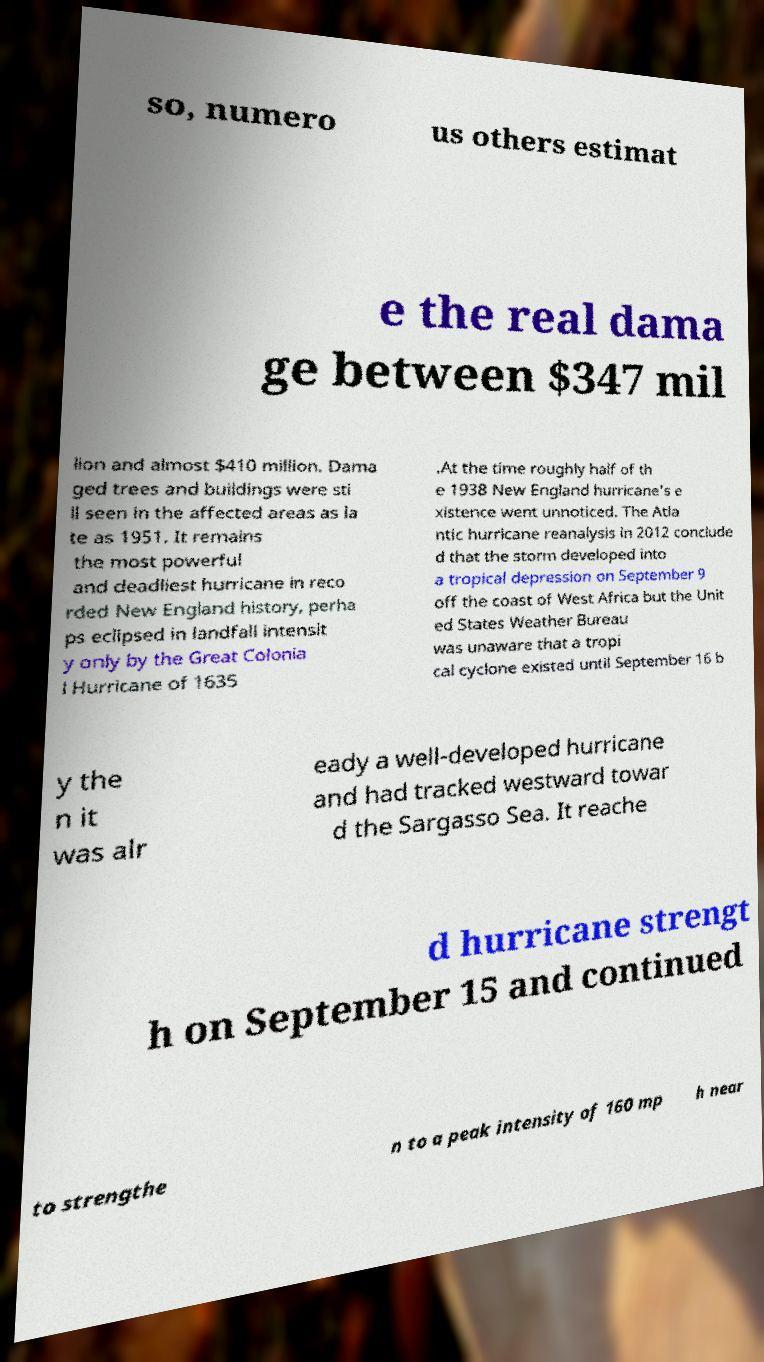Please identify and transcribe the text found in this image. so, numero us others estimat e the real dama ge between $347 mil lion and almost $410 million. Dama ged trees and buildings were sti ll seen in the affected areas as la te as 1951. It remains the most powerful and deadliest hurricane in reco rded New England history, perha ps eclipsed in landfall intensit y only by the Great Colonia l Hurricane of 1635 .At the time roughly half of th e 1938 New England hurricane's e xistence went unnoticed. The Atla ntic hurricane reanalysis in 2012 conclude d that the storm developed into a tropical depression on September 9 off the coast of West Africa but the Unit ed States Weather Bureau was unaware that a tropi cal cyclone existed until September 16 b y the n it was alr eady a well-developed hurricane and had tracked westward towar d the Sargasso Sea. It reache d hurricane strengt h on September 15 and continued to strengthe n to a peak intensity of 160 mp h near 